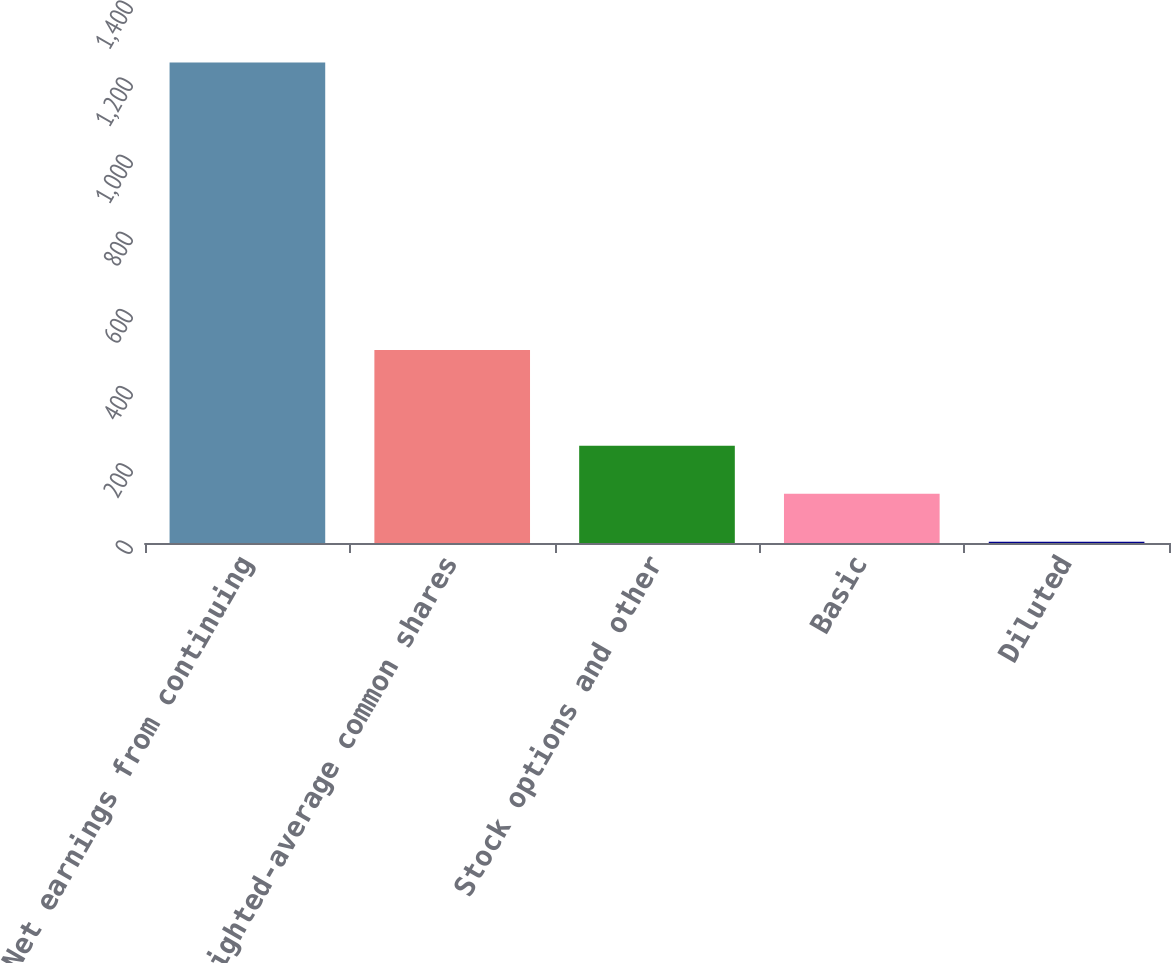Convert chart. <chart><loc_0><loc_0><loc_500><loc_500><bar_chart><fcel>Net earnings from continuing<fcel>Weighted-average common shares<fcel>Stock options and other<fcel>Basic<fcel>Diluted<nl><fcel>1246<fcel>500.53<fcel>252.03<fcel>127.78<fcel>3.53<nl></chart> 